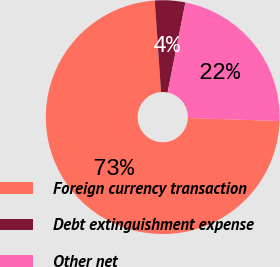Convert chart to OTSL. <chart><loc_0><loc_0><loc_500><loc_500><pie_chart><fcel>Foreign currency transaction<fcel>Debt extinguishment expense<fcel>Other net<nl><fcel>73.38%<fcel>4.2%<fcel>22.42%<nl></chart> 